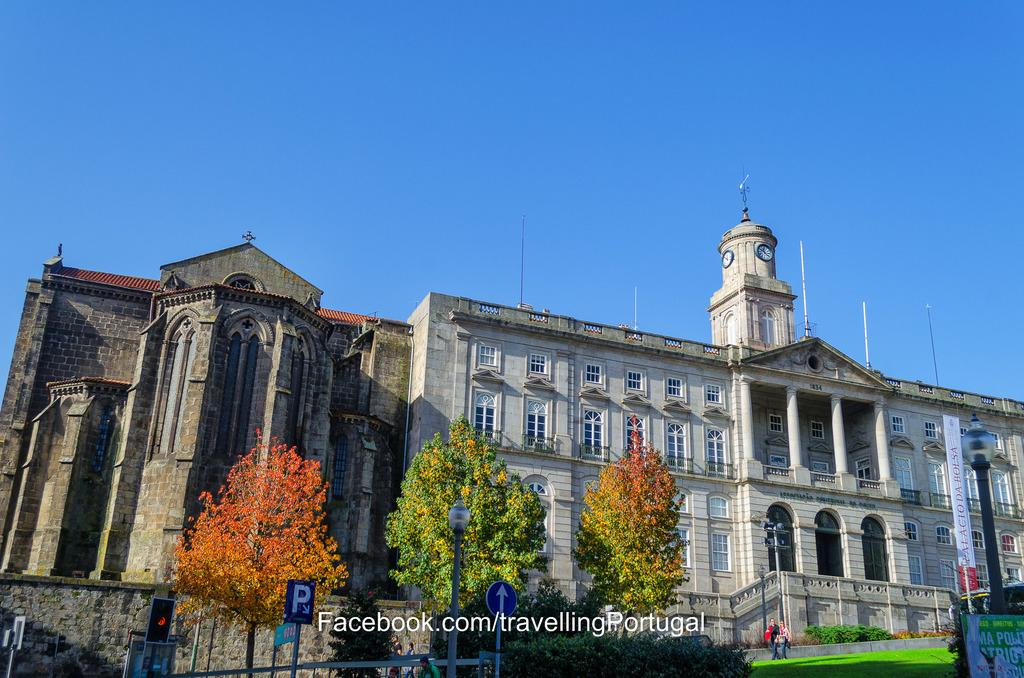<image>
Create a compact narrative representing the image presented. a ornate old building with a clock tower and Facebook.com imprint over it 